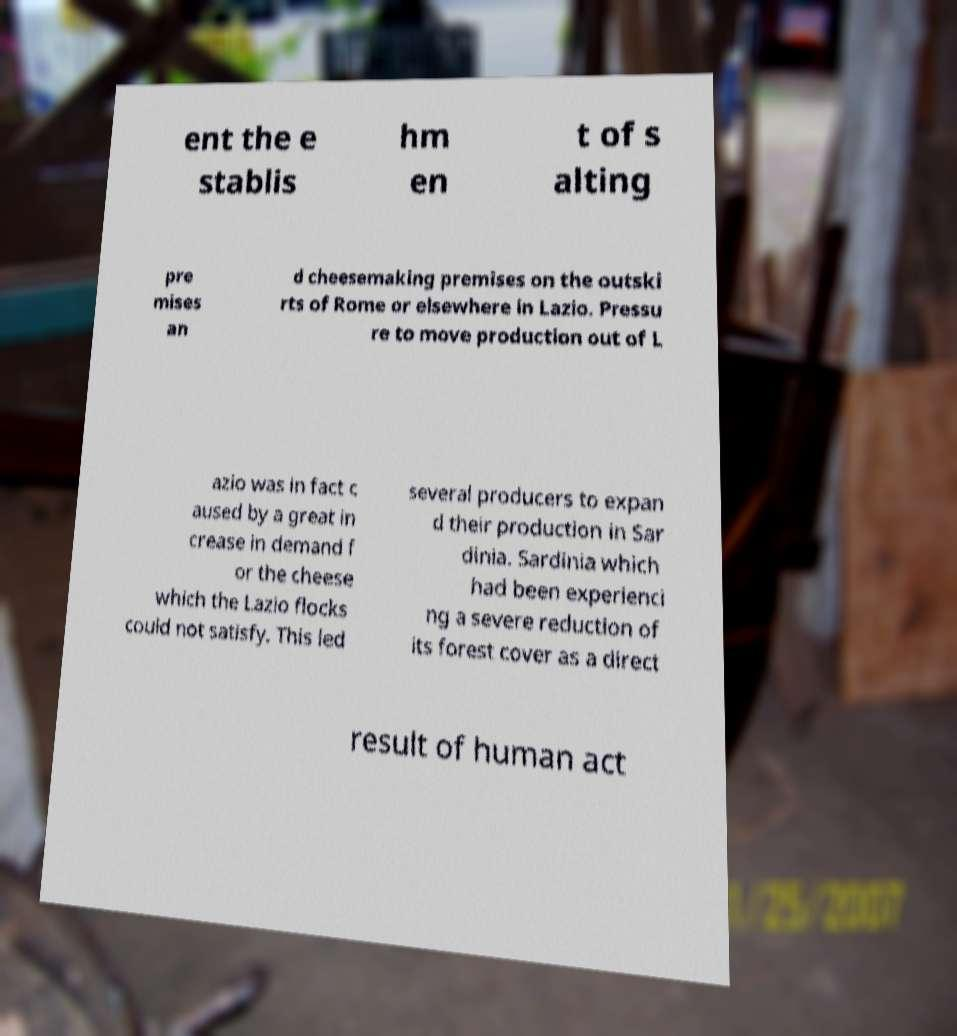Can you read and provide the text displayed in the image?This photo seems to have some interesting text. Can you extract and type it out for me? ent the e stablis hm en t of s alting pre mises an d cheesemaking premises on the outski rts of Rome or elsewhere in Lazio. Pressu re to move production out of L azio was in fact c aused by a great in crease in demand f or the cheese which the Lazio flocks could not satisfy. This led several producers to expan d their production in Sar dinia. Sardinia which had been experienci ng a severe reduction of its forest cover as a direct result of human act 